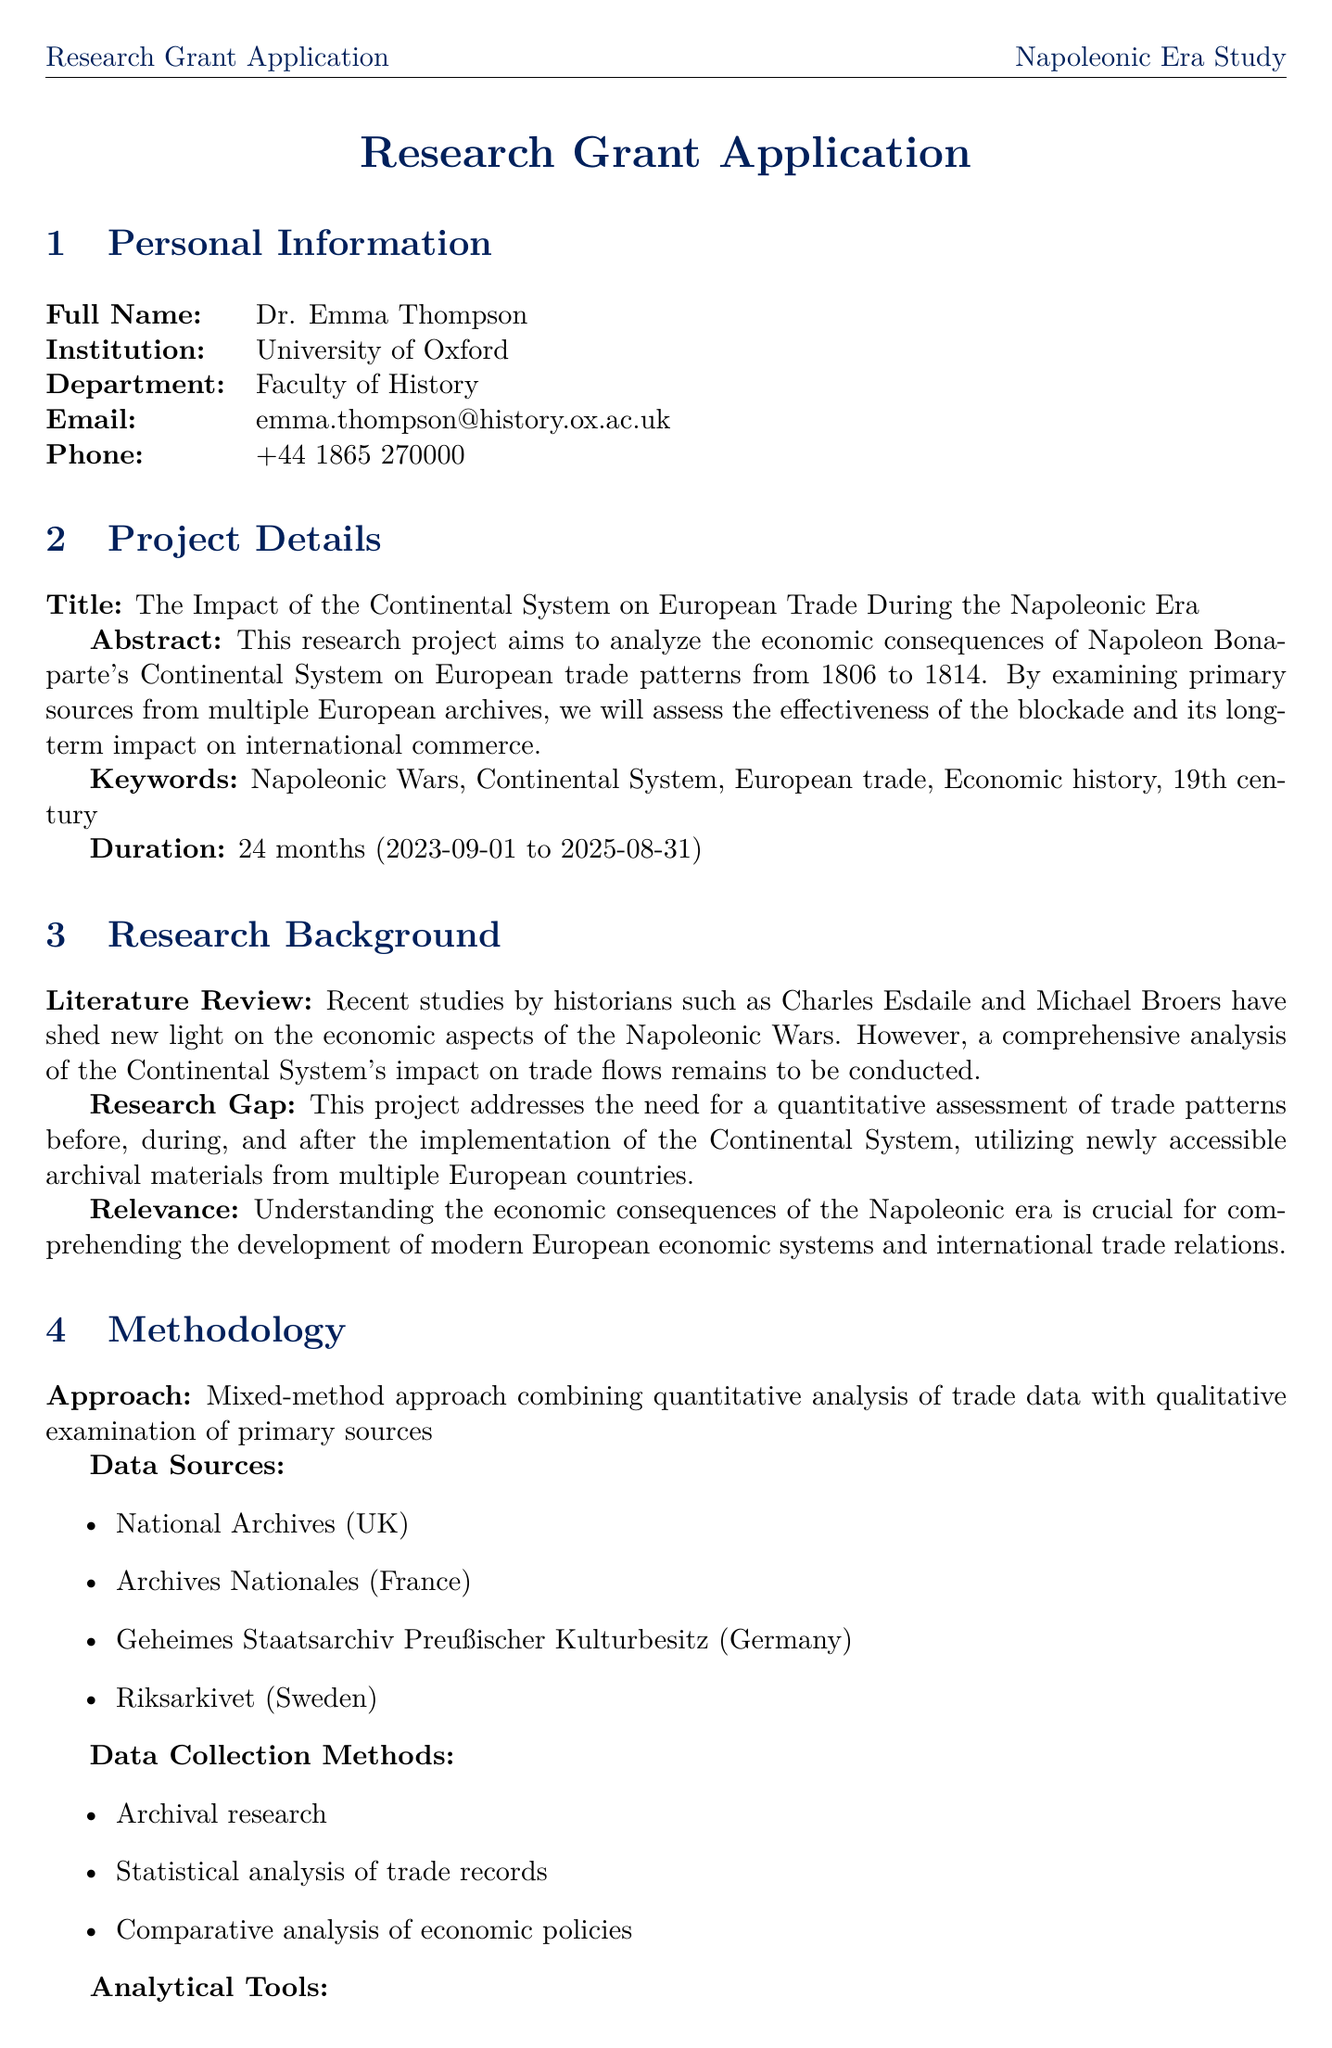What is the full name of the principal investigator? The document specifies the full name of the principal investigator under personal information.
Answer: Dr. Emma Thompson What is the total budget amount? The budget section of the document contains the total amount allocated for the research project.
Answer: 75000 What is the project duration? The project duration is explicitly stated in the project details section of the document.
Answer: 24 months In which month does data collection and archival research begin? The timeline outlines when each phase starts, including data collection and archival research.
Answer: December What methodological approach is being used in the study? The methodology section describes the approach that will be followed in conducting the research.
Answer: Mixed-method approach How much is allocated for Travel and Accommodation? The budget breakdown provides specific amounts for each category, including travel expenses.
Answer: 15000 Which software will be used for qualitative data analysis? The analytical tools listed in the methodology section include the software for qualitative analysis.
Answer: NVivo What are the expected outcomes for this research project? The expected outcomes section details what the project anticipates delivering upon completion.
Answer: Peer-reviewed journal articles What is the start date of the project? The project details section includes specific dates relating to the commencement of the research project.
Answer: 2023-09-01 